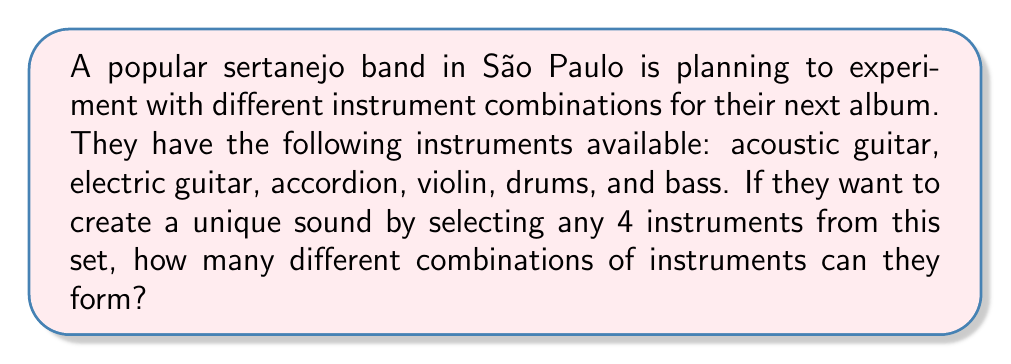Teach me how to tackle this problem. To solve this problem, we need to use the combination formula. We are selecting 4 instruments out of a total of 6 instruments, where the order doesn't matter (since we're only interested in which instruments are used, not the order they're played in).

The combination formula is:

$$ C(n,r) = \frac{n!}{r!(n-r)!} $$

Where:
$n$ is the total number of items to choose from (in this case, 6 instruments)
$r$ is the number of items being chosen (in this case, 4 instruments)

Let's plug in our values:

$$ C(6,4) = \frac{6!}{4!(6-4)!} = \frac{6!}{4!2!} $$

Now, let's calculate this step by step:

1) First, expand this:
   $$ \frac{6 \times 5 \times 4!}{4! \times 2 \times 1} $$

2) The 4! cancels out in the numerator and denominator:
   $$ \frac{6 \times 5}{2 \times 1} $$

3) Multiply the numerator and denominator:
   $$ \frac{30}{2} $$

4) Divide:
   $$ 15 $$

Therefore, the sertanejo band can form 15 different combinations of 4 instruments from their set of 6 instruments.
Answer: 15 combinations 